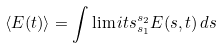Convert formula to latex. <formula><loc_0><loc_0><loc_500><loc_500>\langle E ( t ) \rangle = \int \lim i t s _ { s _ { 1 } } ^ { s _ { 2 } } E ( s , t ) \, d s</formula> 